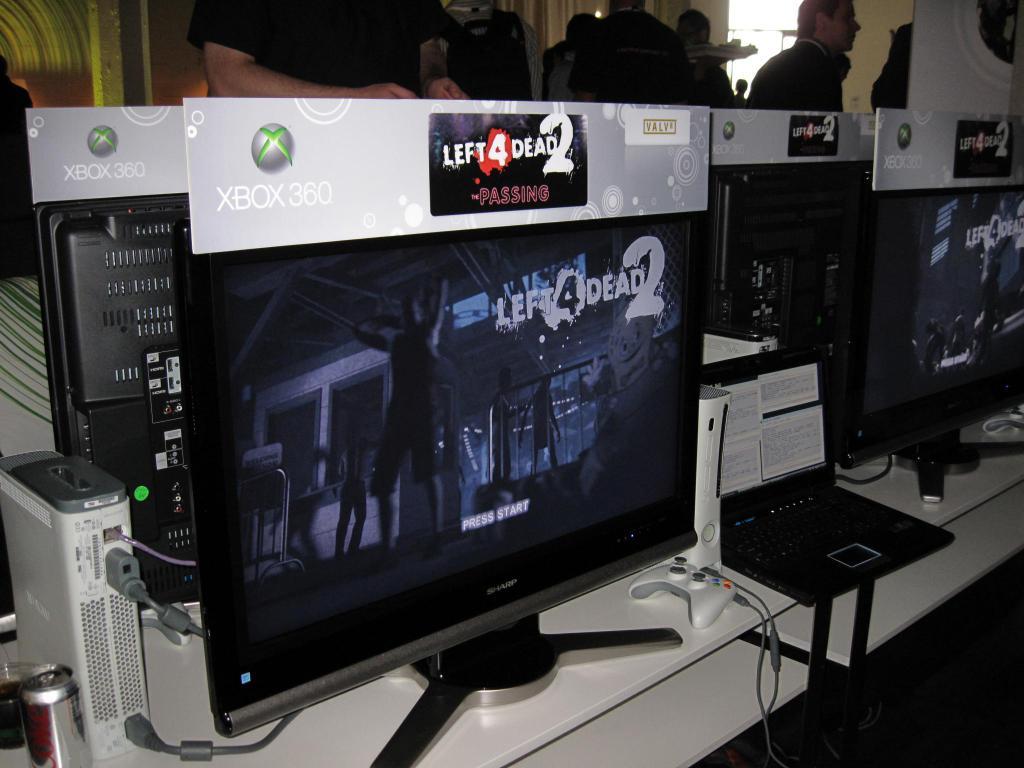Is left for dead 2 a movie or game?
Offer a terse response. Game. 